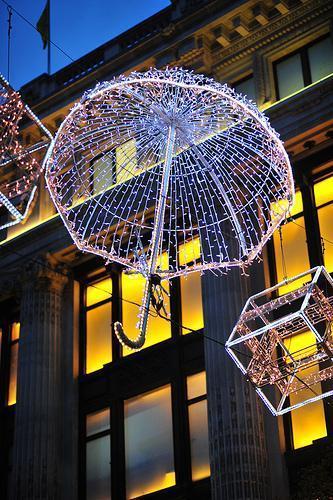How many umbrellas are there?
Give a very brief answer. 1. How many cubes are there?
Give a very brief answer. 2. 